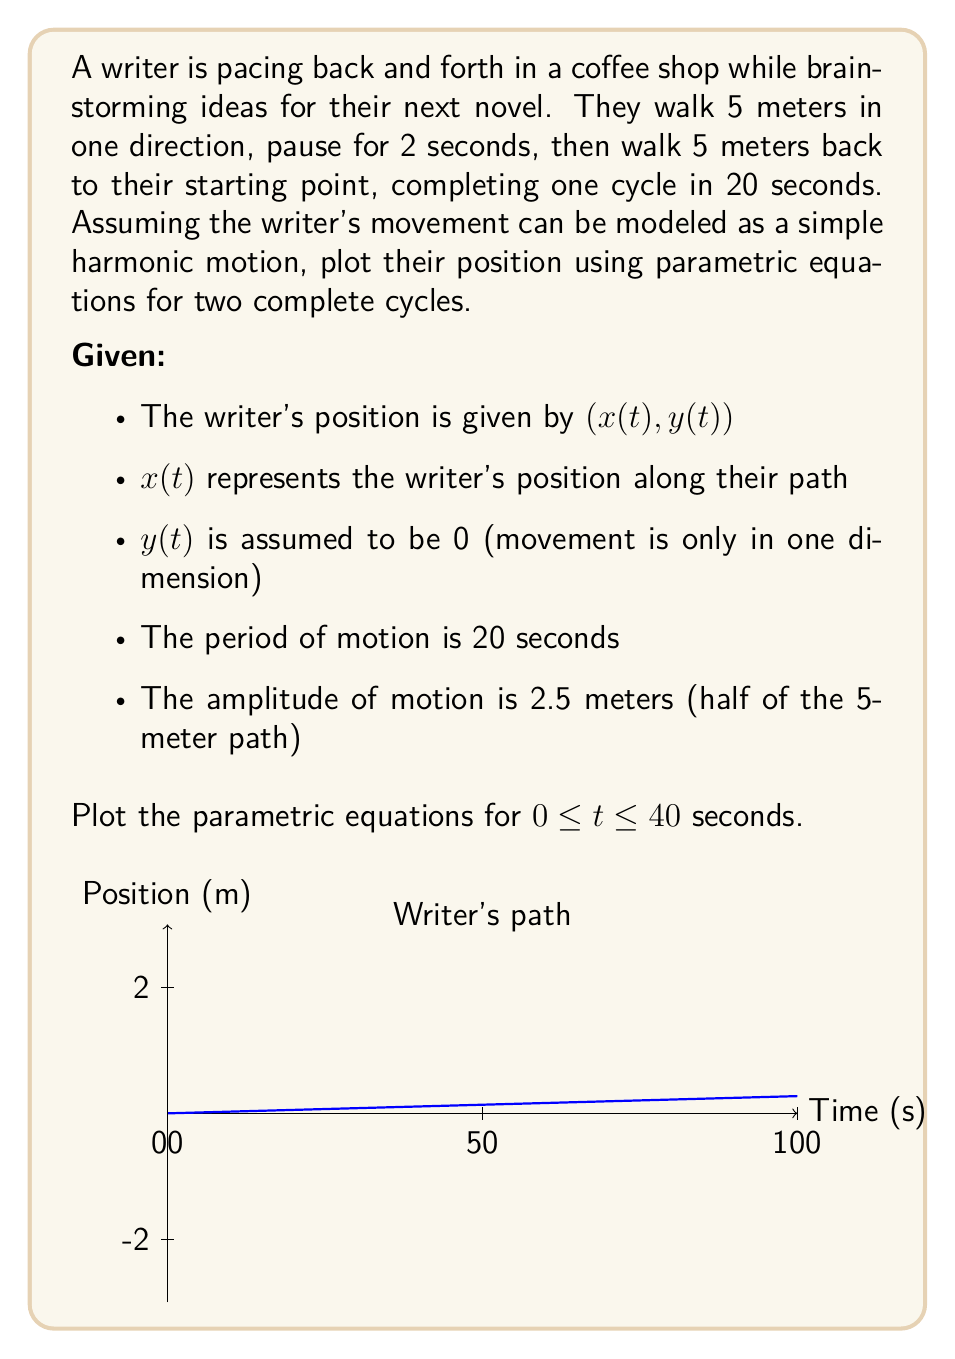Teach me how to tackle this problem. To solve this problem, we'll follow these steps:

1) First, let's determine the angular frequency $\omega$:
   $$\omega = \frac{2\pi}{T} = \frac{2\pi}{20} = \frac{\pi}{10} \text{ rad/s}$$

2) The general form of simple harmonic motion is:
   $$x(t) = A \sin(\omega t + \phi)$$
   where $A$ is the amplitude, $\omega$ is the angular frequency, and $\phi$ is the phase shift.

3) In this case:
   - $A = 2.5$ meters (half of the 5-meter path)
   - $\omega = \frac{\pi}{10}$ rad/s
   - $\phi = 0$ (we can assume the writer starts at the middle of their path)

4) Therefore, our parametric equations are:
   $$x(t) = 2.5 \sin(\frac{\pi t}{10})$$
   $$y(t) = 0$$

5) These equations describe the writer's position for $0 \leq t \leq 40$ seconds, which covers two complete cycles.

6) To plot these equations:
   - The x-axis represents time t from 0 to 40 seconds
   - The y-axis represents the writer's position x(t) from -2.5 to 2.5 meters
   - The resulting graph will be a sinusoidal wave

The graph shown in the question visualizes this motion, with the blue curve representing the writer's position over time.
Answer: $$x(t) = 2.5 \sin(\frac{\pi t}{10}), y(t) = 0, 0 \leq t \leq 40$$ 